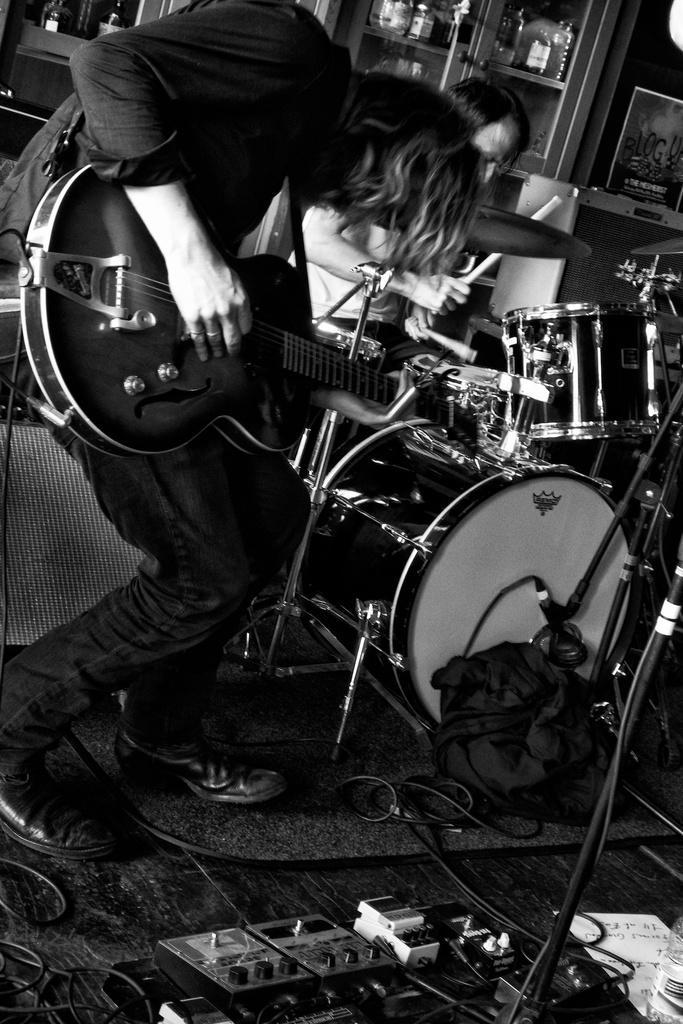How would you summarize this image in a sentence or two? In the image we can see there is a person who is standing and holding guitar in his hand and in the image we can see there are other musical instruments and the image is in black and white colour. 